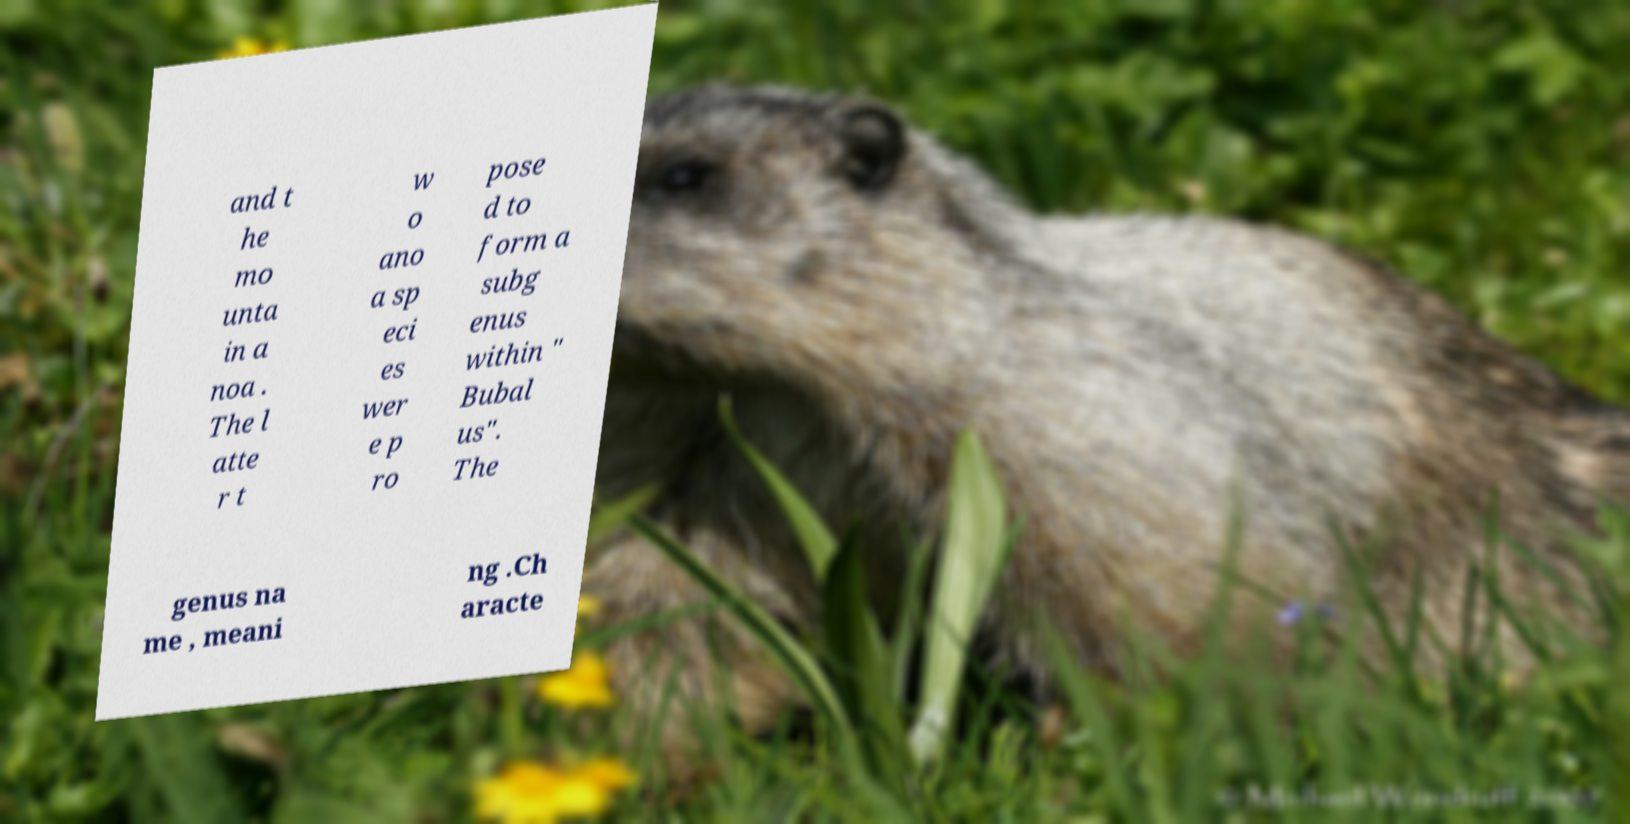Please identify and transcribe the text found in this image. and t he mo unta in a noa . The l atte r t w o ano a sp eci es wer e p ro pose d to form a subg enus within " Bubal us". The genus na me , meani ng .Ch aracte 